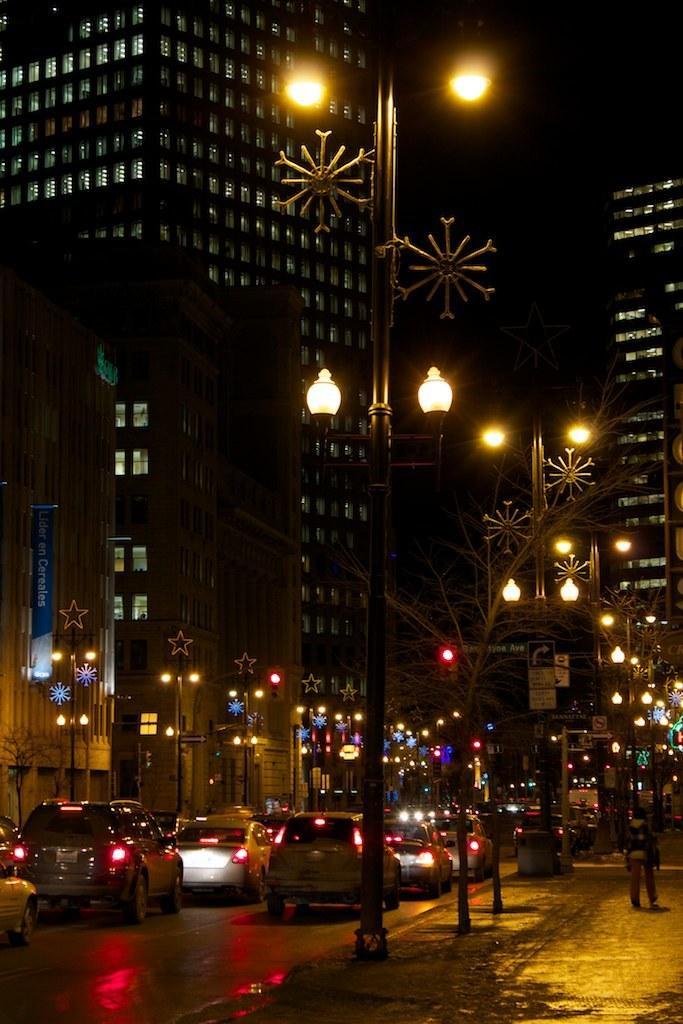Can you describe this image briefly? In this picture there is a person and we can see lights and decorative items on poles, vehicles on the road and trees. In the background of the image we can see buildings, boards, banner and it is dark. 